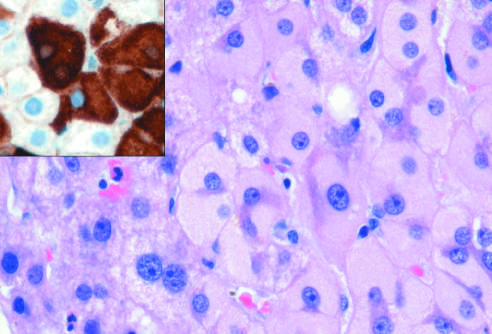does hematoxylin-eosin staining show the presence of abundant, finely granular pink cytoplasmic inclusions?
Answer the question using a single word or phrase. Yes 